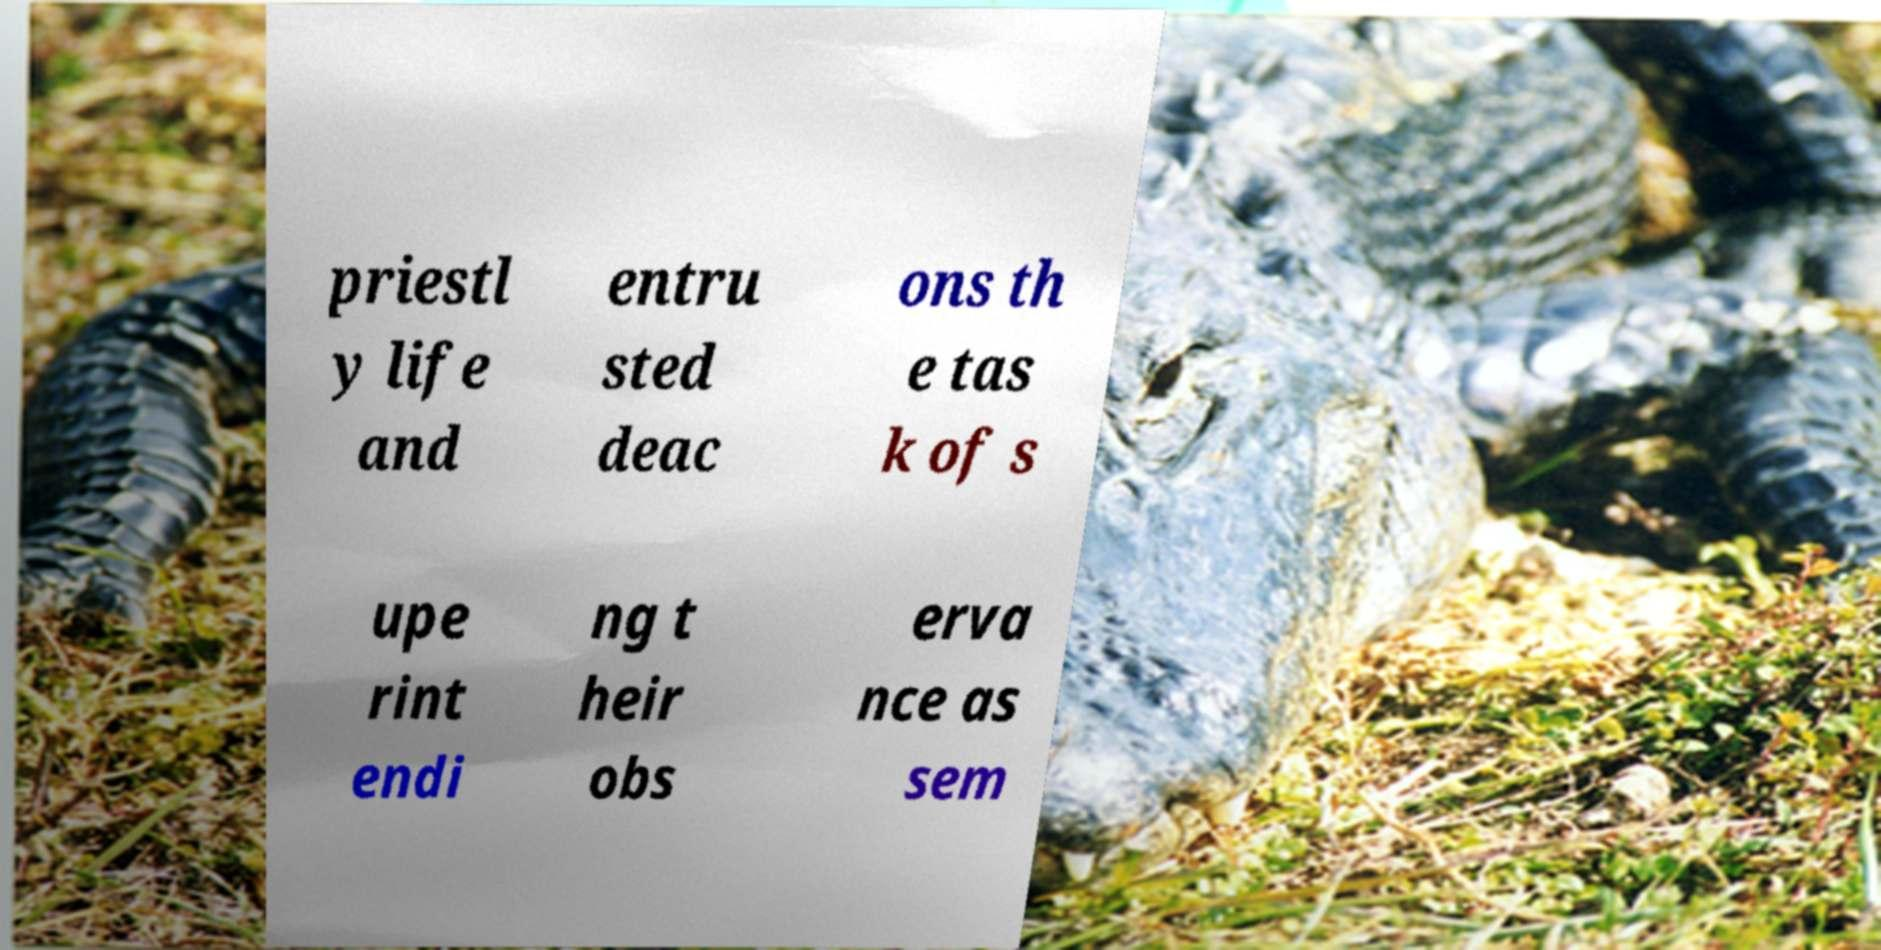I need the written content from this picture converted into text. Can you do that? priestl y life and entru sted deac ons th e tas k of s upe rint endi ng t heir obs erva nce as sem 